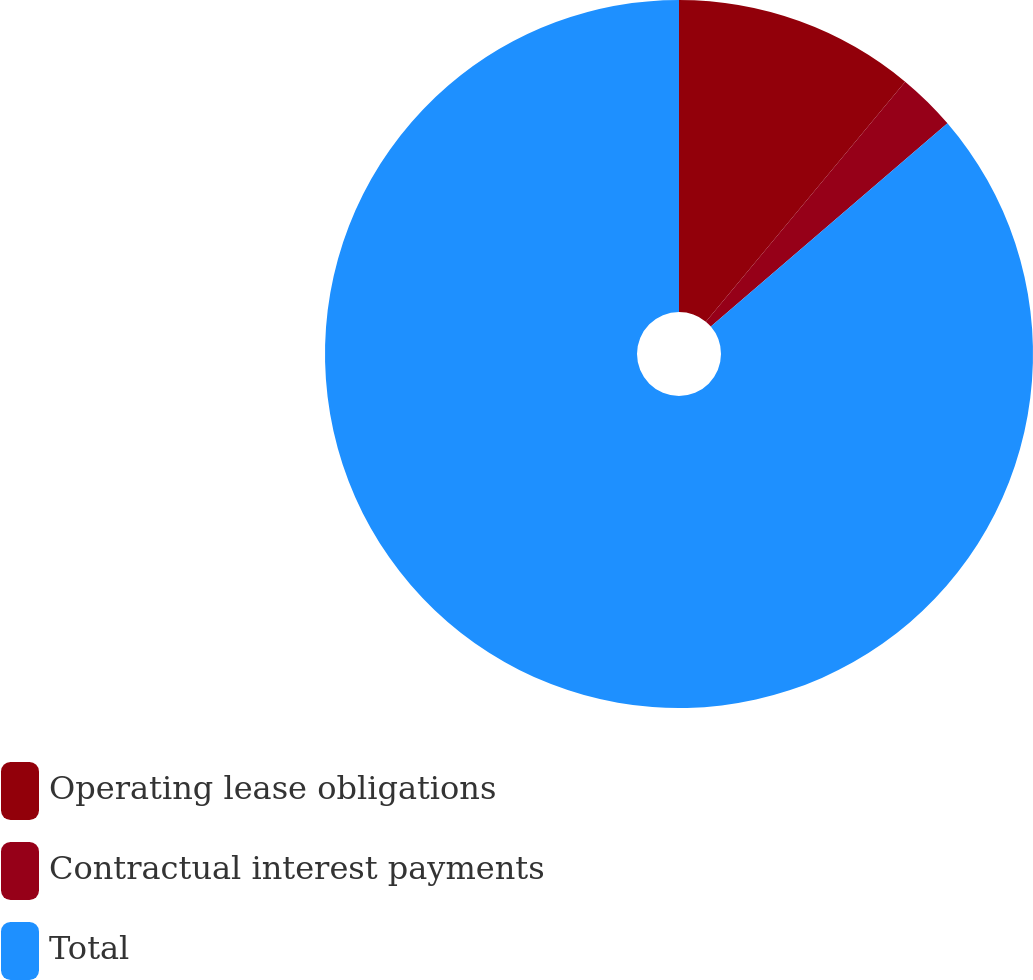Convert chart. <chart><loc_0><loc_0><loc_500><loc_500><pie_chart><fcel>Operating lease obligations<fcel>Contractual interest payments<fcel>Total<nl><fcel>11.03%<fcel>2.67%<fcel>86.3%<nl></chart> 